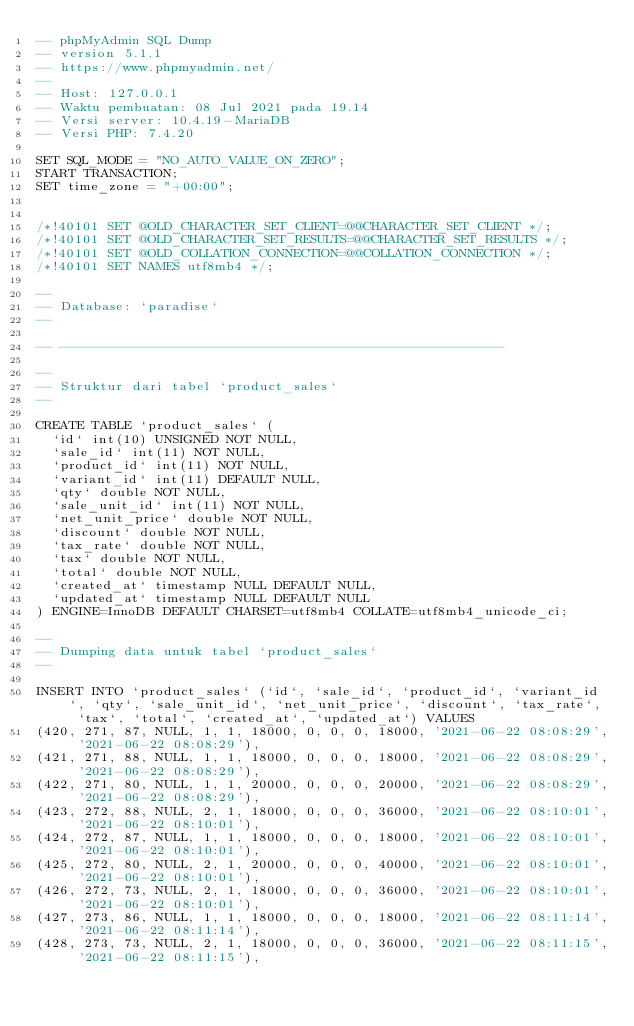<code> <loc_0><loc_0><loc_500><loc_500><_SQL_>-- phpMyAdmin SQL Dump
-- version 5.1.1
-- https://www.phpmyadmin.net/
--
-- Host: 127.0.0.1
-- Waktu pembuatan: 08 Jul 2021 pada 19.14
-- Versi server: 10.4.19-MariaDB
-- Versi PHP: 7.4.20

SET SQL_MODE = "NO_AUTO_VALUE_ON_ZERO";
START TRANSACTION;
SET time_zone = "+00:00";


/*!40101 SET @OLD_CHARACTER_SET_CLIENT=@@CHARACTER_SET_CLIENT */;
/*!40101 SET @OLD_CHARACTER_SET_RESULTS=@@CHARACTER_SET_RESULTS */;
/*!40101 SET @OLD_COLLATION_CONNECTION=@@COLLATION_CONNECTION */;
/*!40101 SET NAMES utf8mb4 */;

--
-- Database: `paradise`
--

-- --------------------------------------------------------

--
-- Struktur dari tabel `product_sales`
--

CREATE TABLE `product_sales` (
  `id` int(10) UNSIGNED NOT NULL,
  `sale_id` int(11) NOT NULL,
  `product_id` int(11) NOT NULL,
  `variant_id` int(11) DEFAULT NULL,
  `qty` double NOT NULL,
  `sale_unit_id` int(11) NOT NULL,
  `net_unit_price` double NOT NULL,
  `discount` double NOT NULL,
  `tax_rate` double NOT NULL,
  `tax` double NOT NULL,
  `total` double NOT NULL,
  `created_at` timestamp NULL DEFAULT NULL,
  `updated_at` timestamp NULL DEFAULT NULL
) ENGINE=InnoDB DEFAULT CHARSET=utf8mb4 COLLATE=utf8mb4_unicode_ci;

--
-- Dumping data untuk tabel `product_sales`
--

INSERT INTO `product_sales` (`id`, `sale_id`, `product_id`, `variant_id`, `qty`, `sale_unit_id`, `net_unit_price`, `discount`, `tax_rate`, `tax`, `total`, `created_at`, `updated_at`) VALUES
(420, 271, 87, NULL, 1, 1, 18000, 0, 0, 0, 18000, '2021-06-22 08:08:29', '2021-06-22 08:08:29'),
(421, 271, 88, NULL, 1, 1, 18000, 0, 0, 0, 18000, '2021-06-22 08:08:29', '2021-06-22 08:08:29'),
(422, 271, 80, NULL, 1, 1, 20000, 0, 0, 0, 20000, '2021-06-22 08:08:29', '2021-06-22 08:08:29'),
(423, 272, 88, NULL, 2, 1, 18000, 0, 0, 0, 36000, '2021-06-22 08:10:01', '2021-06-22 08:10:01'),
(424, 272, 87, NULL, 1, 1, 18000, 0, 0, 0, 18000, '2021-06-22 08:10:01', '2021-06-22 08:10:01'),
(425, 272, 80, NULL, 2, 1, 20000, 0, 0, 0, 40000, '2021-06-22 08:10:01', '2021-06-22 08:10:01'),
(426, 272, 73, NULL, 2, 1, 18000, 0, 0, 0, 36000, '2021-06-22 08:10:01', '2021-06-22 08:10:01'),
(427, 273, 86, NULL, 1, 1, 18000, 0, 0, 0, 18000, '2021-06-22 08:11:14', '2021-06-22 08:11:14'),
(428, 273, 73, NULL, 2, 1, 18000, 0, 0, 0, 36000, '2021-06-22 08:11:15', '2021-06-22 08:11:15'),</code> 